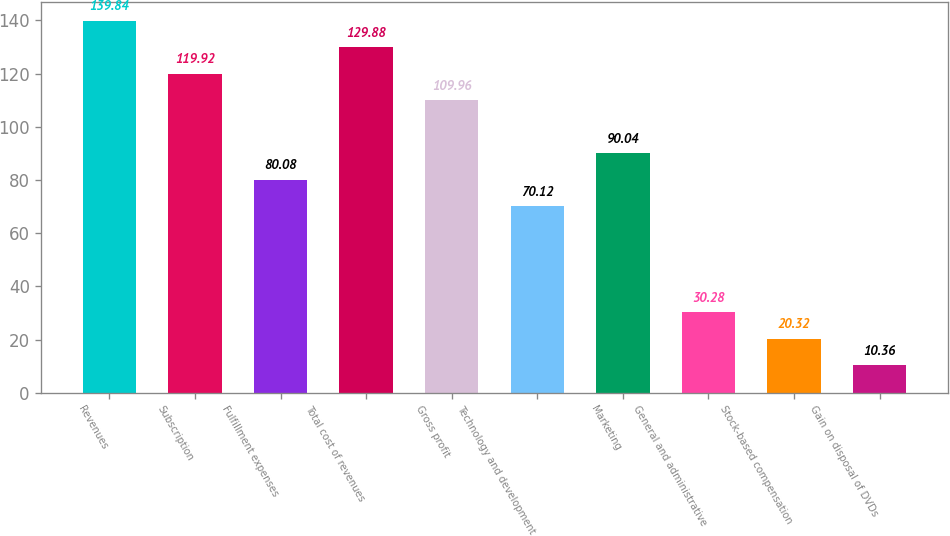Convert chart. <chart><loc_0><loc_0><loc_500><loc_500><bar_chart><fcel>Revenues<fcel>Subscription<fcel>Fulfillment expenses<fcel>Total cost of revenues<fcel>Gross profit<fcel>Technology and development<fcel>Marketing<fcel>General and administrative<fcel>Stock-based compensation<fcel>Gain on disposal of DVDs<nl><fcel>139.84<fcel>119.92<fcel>80.08<fcel>129.88<fcel>109.96<fcel>70.12<fcel>90.04<fcel>30.28<fcel>20.32<fcel>10.36<nl></chart> 